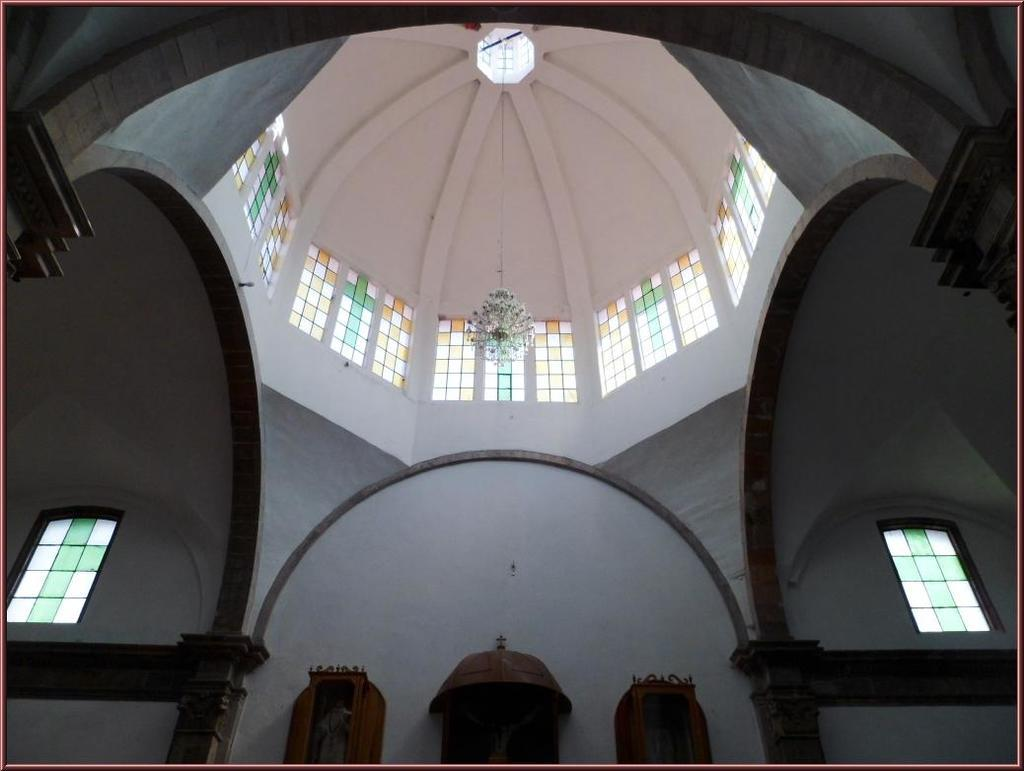What type of location is depicted in the image? The image shows the inside of a building. What can be observed about the roof of the building? The architecture of the roof is visible in the image. Are there any openings in the walls of the building? Yes, there are windows in the walls of the building. What type of oatmeal is being prepared in the image? There is no oatmeal present in the image, as it depicts the inside of a building with a focus on the roof and windows. 